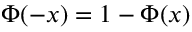Convert formula to latex. <formula><loc_0><loc_0><loc_500><loc_500>\Phi ( - x ) = 1 - \Phi ( x )</formula> 